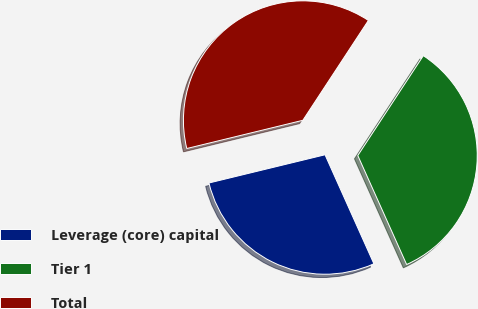<chart> <loc_0><loc_0><loc_500><loc_500><pie_chart><fcel>Leverage (core) capital<fcel>Tier 1<fcel>Total<nl><fcel>27.91%<fcel>34.05%<fcel>38.04%<nl></chart> 